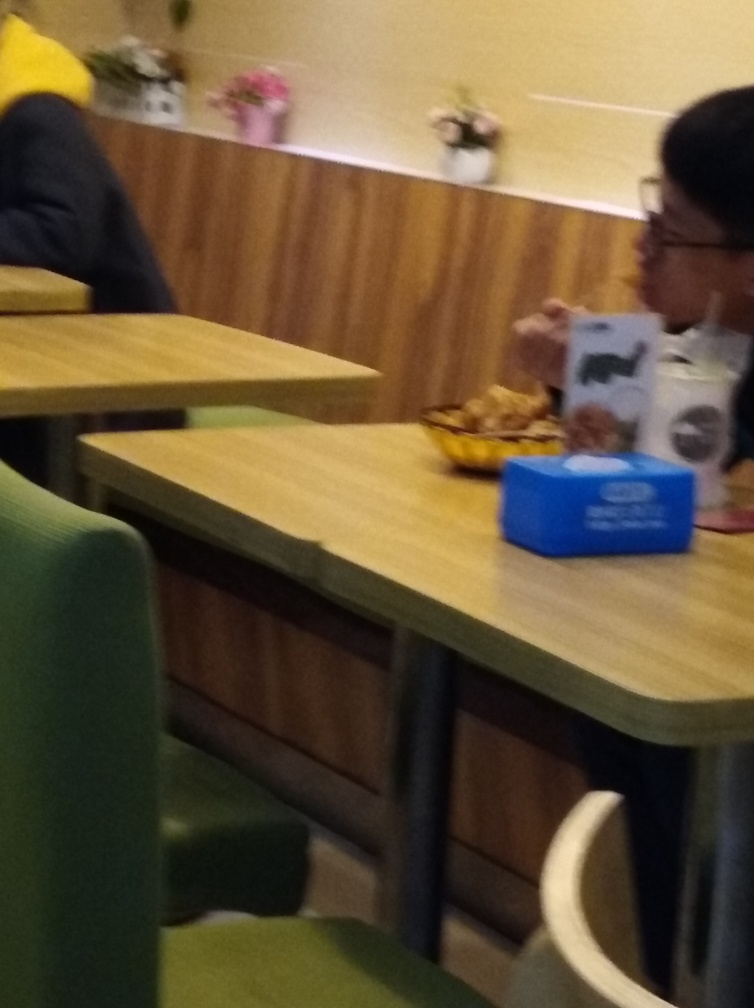What might be the reason for the blurriness of the image? The blurriness of the image could be due to several factors, including camera shake, improper focus, or a low shutter speed in a dimly lit environment, making the image susceptible to motion blur. Additionally, if this was taken with a mobile device, the hand movement of the photographer at the time of the shot could contribute to the lack of sharpness. 